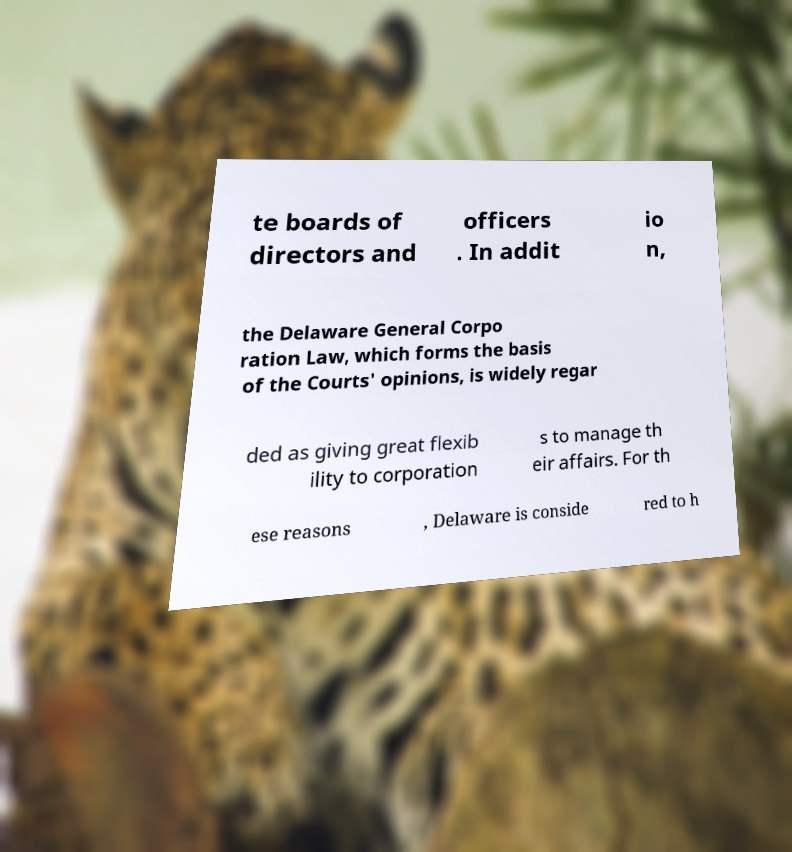Could you extract and type out the text from this image? te boards of directors and officers . In addit io n, the Delaware General Corpo ration Law, which forms the basis of the Courts' opinions, is widely regar ded as giving great flexib ility to corporation s to manage th eir affairs. For th ese reasons , Delaware is conside red to h 